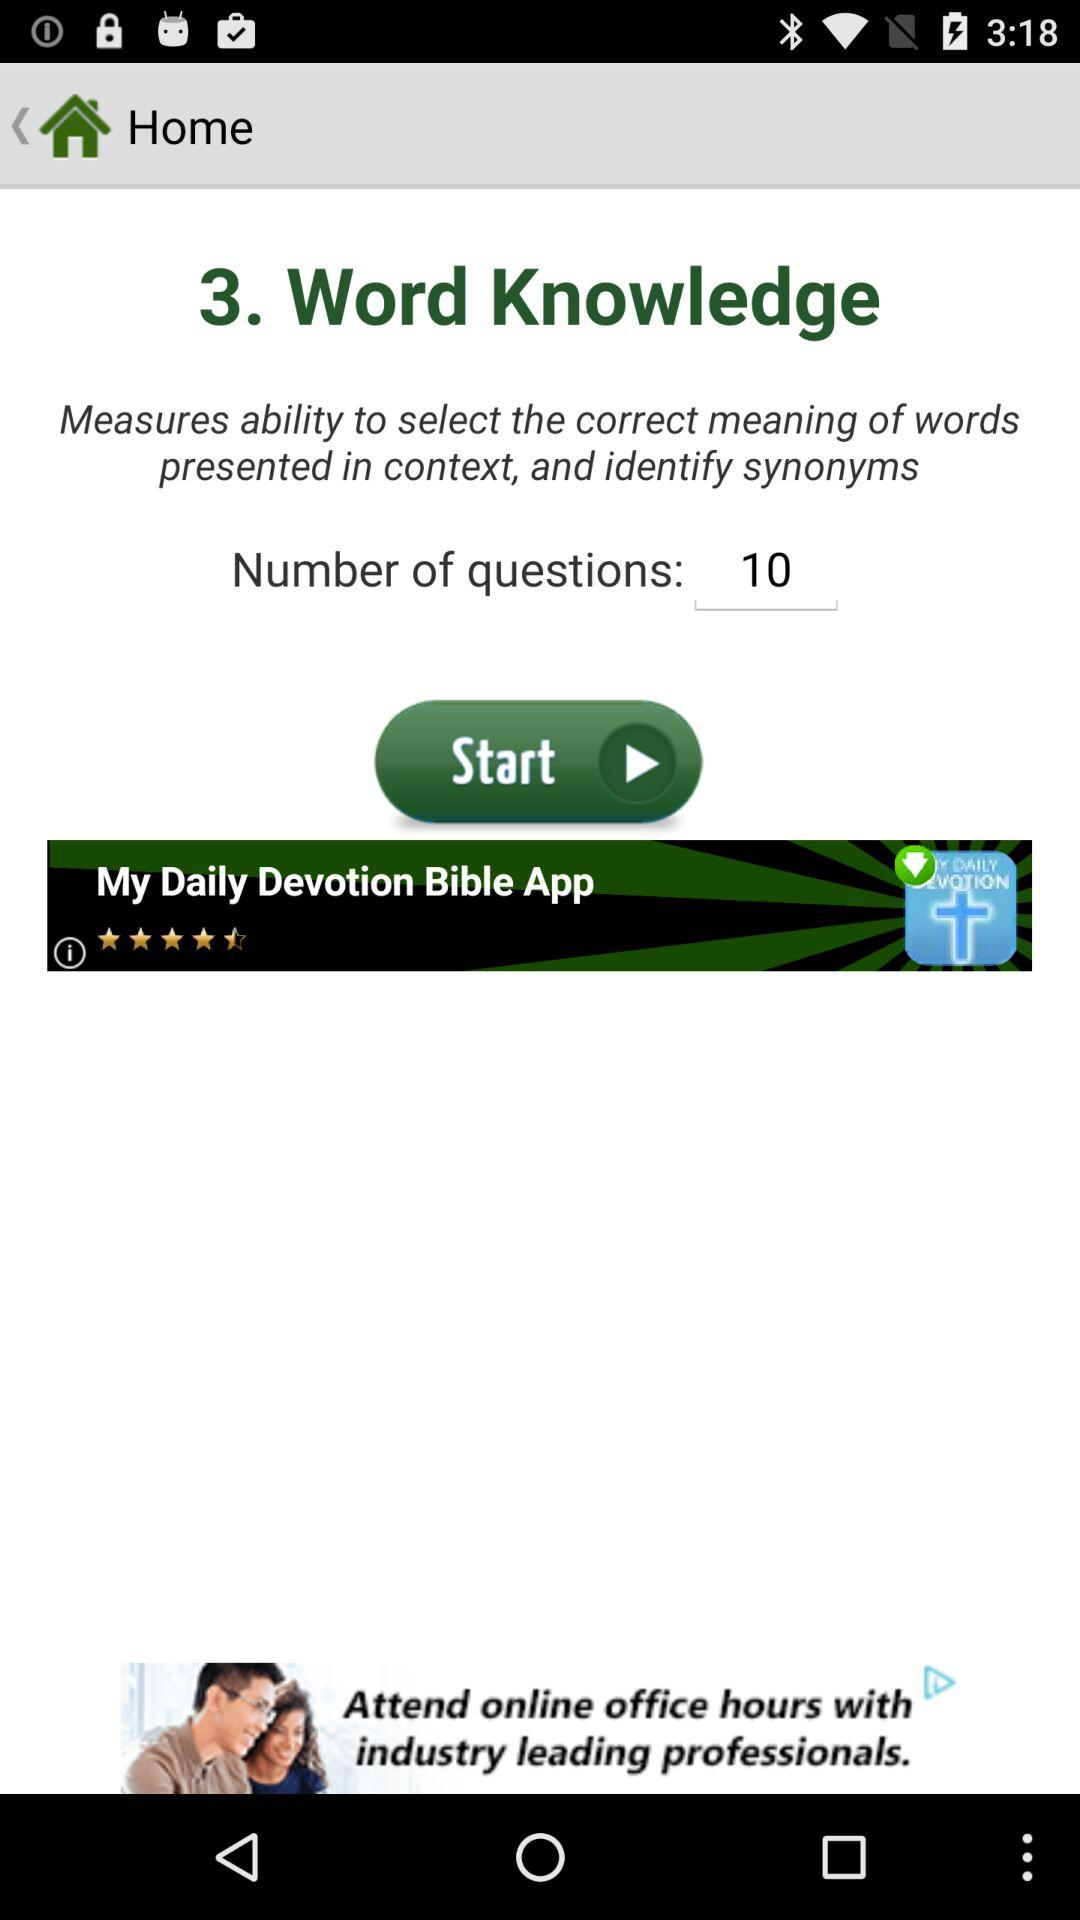How many more questions does the user need to answer to complete the assessment?
Answer the question using a single word or phrase. 10 